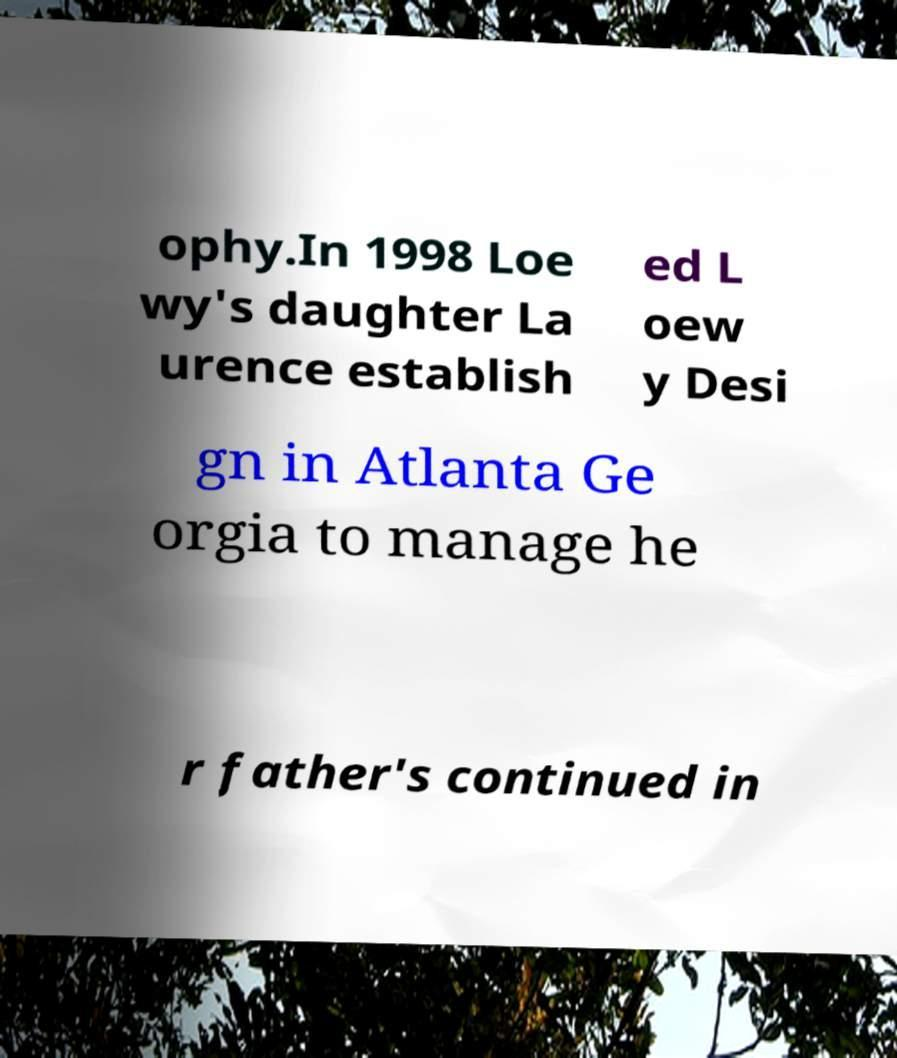Could you assist in decoding the text presented in this image and type it out clearly? ophy.In 1998 Loe wy's daughter La urence establish ed L oew y Desi gn in Atlanta Ge orgia to manage he r father's continued in 